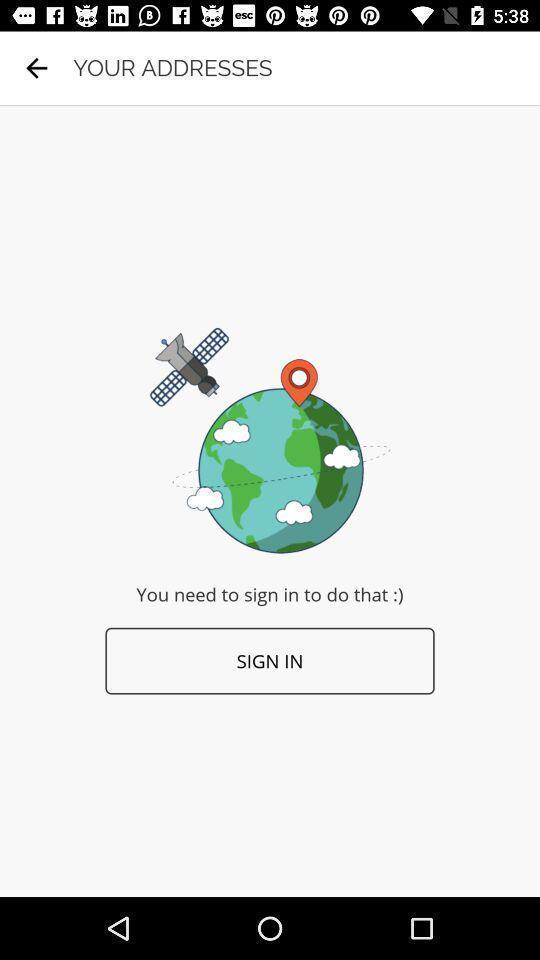What can you discern from this picture? Sign in page. 